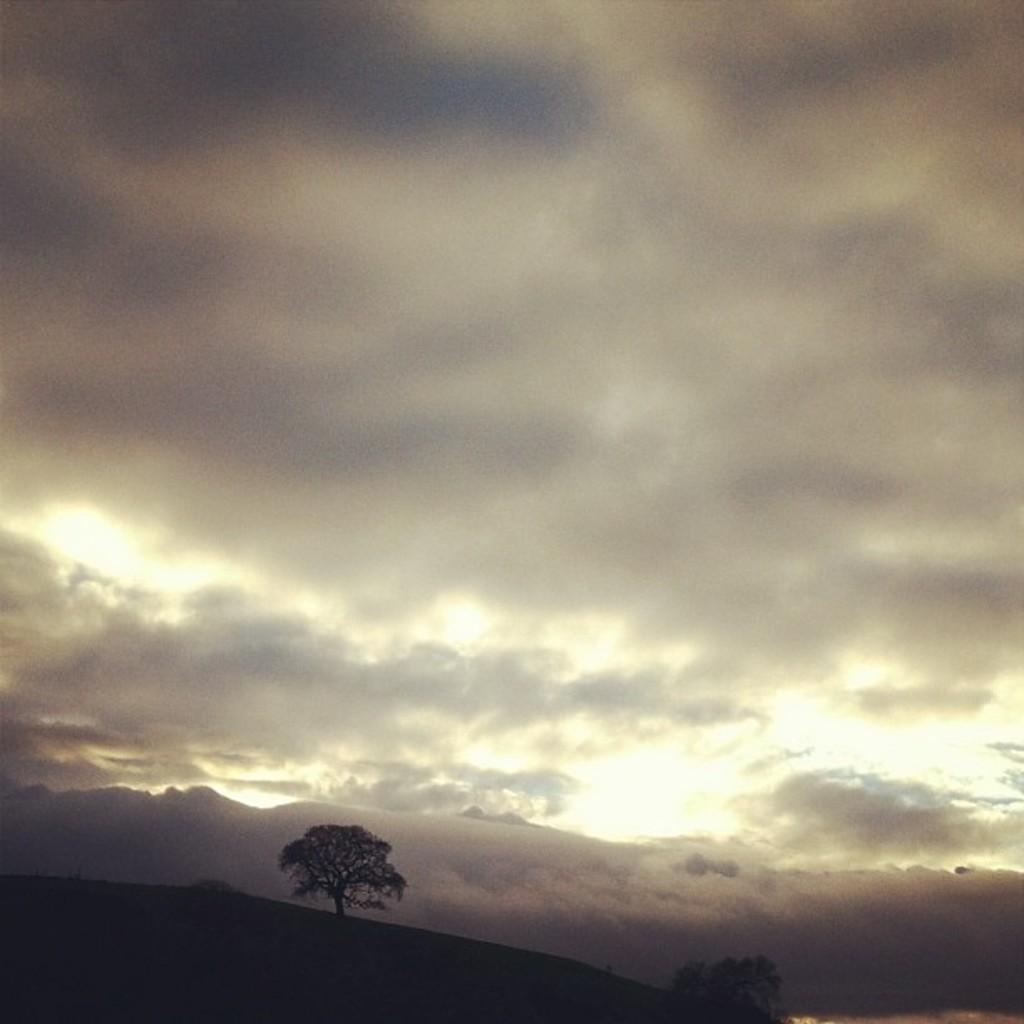What type of vegetation can be seen in the image? There are trees in the image. What is the condition of the sky in the image? The sky is cloudy in the image. How many chickens are present in the image? There are no chickens present in the image; it features trees and a cloudy sky. What type of disease can be seen affecting the trees in the image? There is no disease affecting the trees in the image; the trees appear to be healthy. 